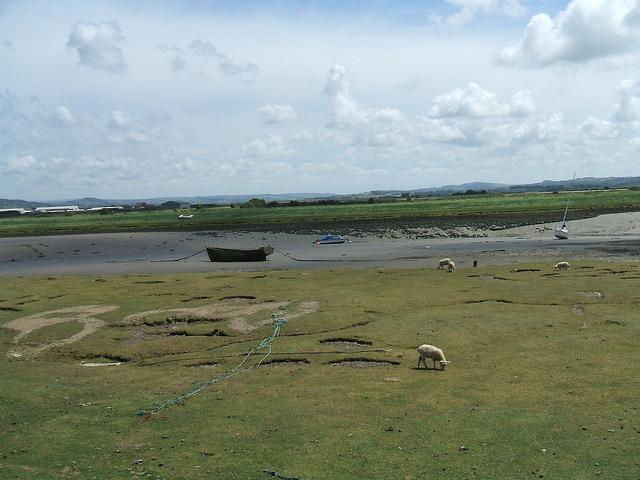What has dried up and stopped the boats from moving?
Indicate the correct choice and explain in the format: 'Answer: answer
Rationale: rationale.'
Options: Water, grass, ice, clouds. Answer: water.
Rationale: Water has dried. 